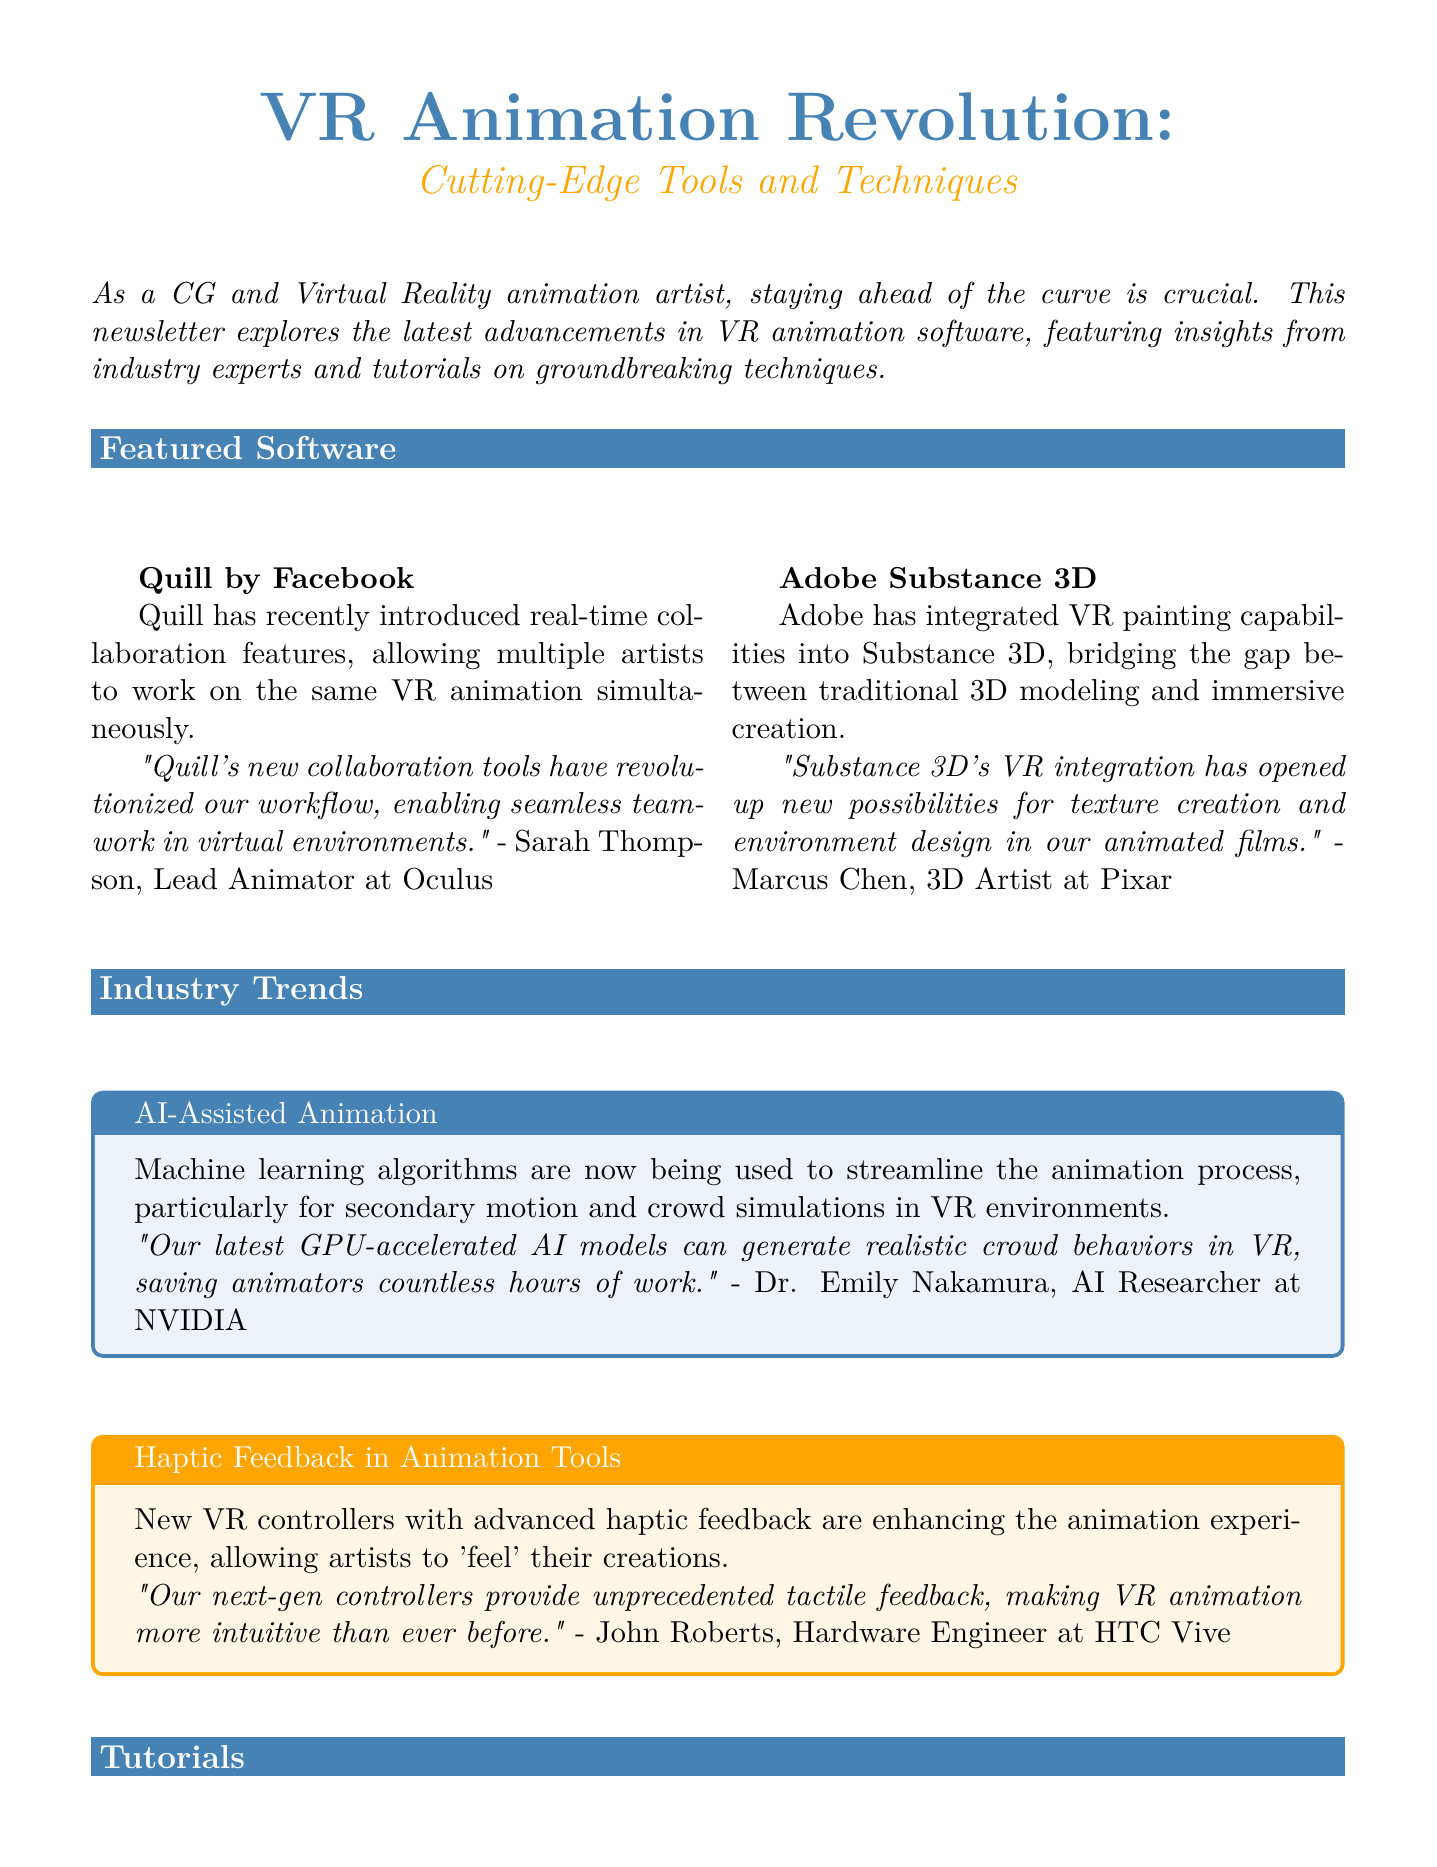What is the title of the newsletter? The title of the newsletter is mentioned at the beginning of the document.
Answer: VR Animation Revolution: Cutting-Edge Tools and Techniques Who provided the expert comment on Quill? The expert comment on Quill is credited to a specific individual in the document.
Answer: Sarah Thompson What is a key feature of Adobe Substance 3D? The document states a key feature that has been integrated into Adobe Substance 3D.
Answer: VR painting capabilities What is the duration of the tutorial titled "Rigging Characters for VR Interaction"? The duration of the tutorial is specified in the tutorial details section.
Answer: 60 minutes What industry trend involves machine learning algorithms? The document identifies a specific trend related to technology in animation.
Answer: AI-Assisted Animation What event will take place in Los Angeles in August 2023? The document lists an upcoming event with location and date details.
Answer: SIGGRAPH 2023 What software is used for the tutorial on creating water effects in VR? The software is explicitly mentioned in the tutorial section of the document.
Answer: Unity 3D What does John Roberts' expert insight focus on? The document relates John's expert insight to a specific innovation in animation tools.
Answer: Haptic feedback Who is the instructor for the water effects tutorial? The name of the instructor for the tutorial is mentioned under that section.
Answer: Maya Patel 